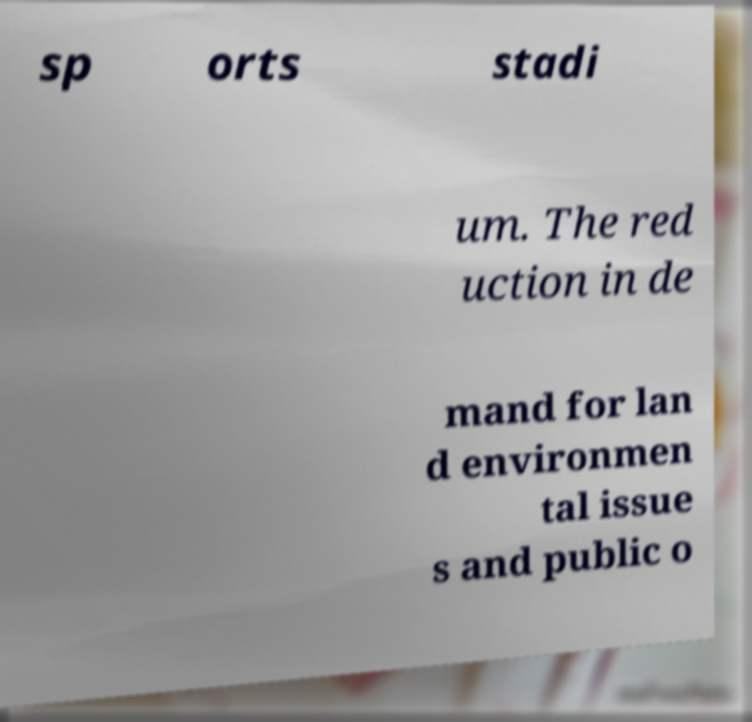Could you extract and type out the text from this image? sp orts stadi um. The red uction in de mand for lan d environmen tal issue s and public o 